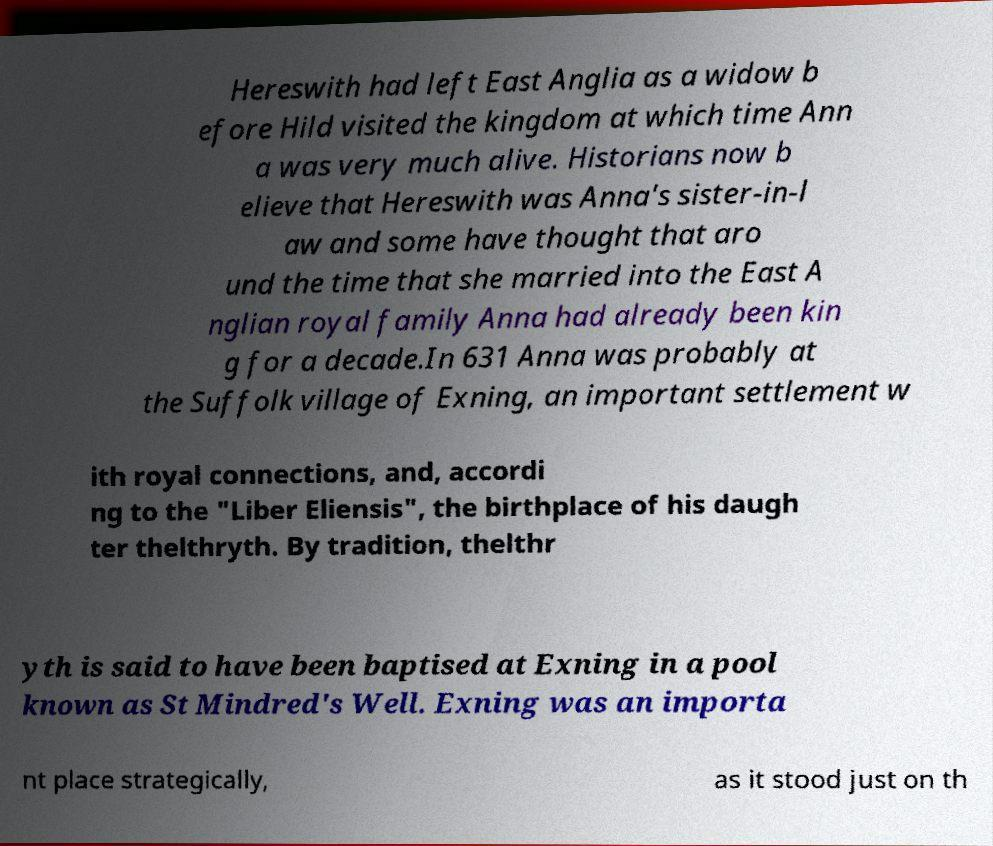Can you accurately transcribe the text from the provided image for me? Hereswith had left East Anglia as a widow b efore Hild visited the kingdom at which time Ann a was very much alive. Historians now b elieve that Hereswith was Anna's sister-in-l aw and some have thought that aro und the time that she married into the East A nglian royal family Anna had already been kin g for a decade.In 631 Anna was probably at the Suffolk village of Exning, an important settlement w ith royal connections, and, accordi ng to the "Liber Eliensis", the birthplace of his daugh ter thelthryth. By tradition, thelthr yth is said to have been baptised at Exning in a pool known as St Mindred's Well. Exning was an importa nt place strategically, as it stood just on th 